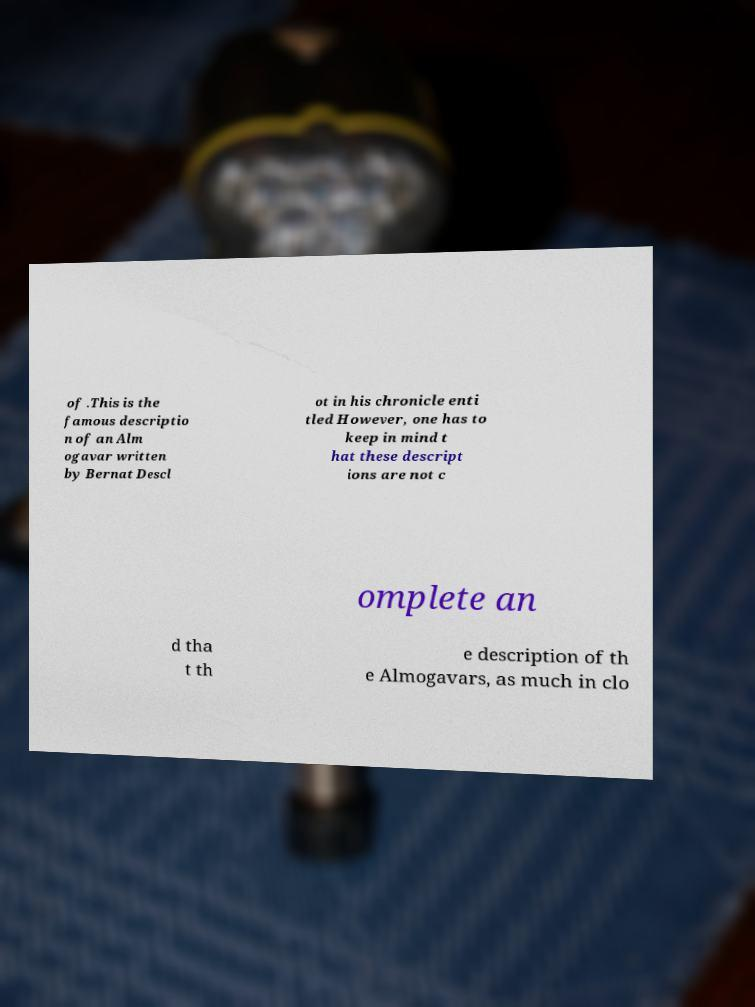For documentation purposes, I need the text within this image transcribed. Could you provide that? of .This is the famous descriptio n of an Alm ogavar written by Bernat Descl ot in his chronicle enti tled However, one has to keep in mind t hat these descript ions are not c omplete an d tha t th e description of th e Almogavars, as much in clo 